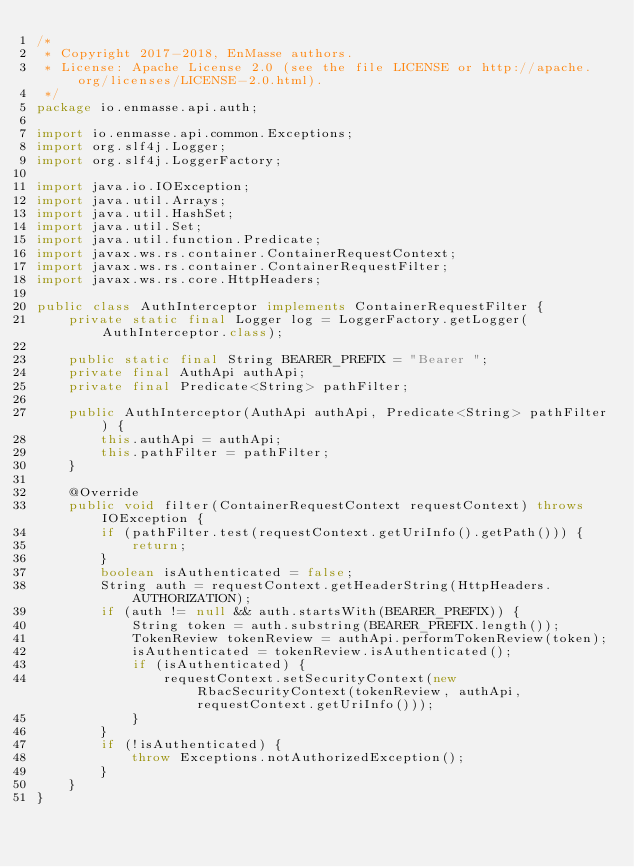Convert code to text. <code><loc_0><loc_0><loc_500><loc_500><_Java_>/*
 * Copyright 2017-2018, EnMasse authors.
 * License: Apache License 2.0 (see the file LICENSE or http://apache.org/licenses/LICENSE-2.0.html).
 */
package io.enmasse.api.auth;

import io.enmasse.api.common.Exceptions;
import org.slf4j.Logger;
import org.slf4j.LoggerFactory;

import java.io.IOException;
import java.util.Arrays;
import java.util.HashSet;
import java.util.Set;
import java.util.function.Predicate;
import javax.ws.rs.container.ContainerRequestContext;
import javax.ws.rs.container.ContainerRequestFilter;
import javax.ws.rs.core.HttpHeaders;

public class AuthInterceptor implements ContainerRequestFilter {
    private static final Logger log = LoggerFactory.getLogger(AuthInterceptor.class);

    public static final String BEARER_PREFIX = "Bearer ";
    private final AuthApi authApi;
    private final Predicate<String> pathFilter;

    public AuthInterceptor(AuthApi authApi, Predicate<String> pathFilter) {
        this.authApi = authApi;
        this.pathFilter = pathFilter;
    }

    @Override
    public void filter(ContainerRequestContext requestContext) throws IOException {
        if (pathFilter.test(requestContext.getUriInfo().getPath())) {
            return;
        }
        boolean isAuthenticated = false;
        String auth = requestContext.getHeaderString(HttpHeaders.AUTHORIZATION);
        if (auth != null && auth.startsWith(BEARER_PREFIX)) {
            String token = auth.substring(BEARER_PREFIX.length());
            TokenReview tokenReview = authApi.performTokenReview(token);
            isAuthenticated = tokenReview.isAuthenticated();
            if (isAuthenticated) {
                requestContext.setSecurityContext(new RbacSecurityContext(tokenReview, authApi, requestContext.getUriInfo()));
            }
        }
        if (!isAuthenticated) {
            throw Exceptions.notAuthorizedException();
        }
    }
}
</code> 